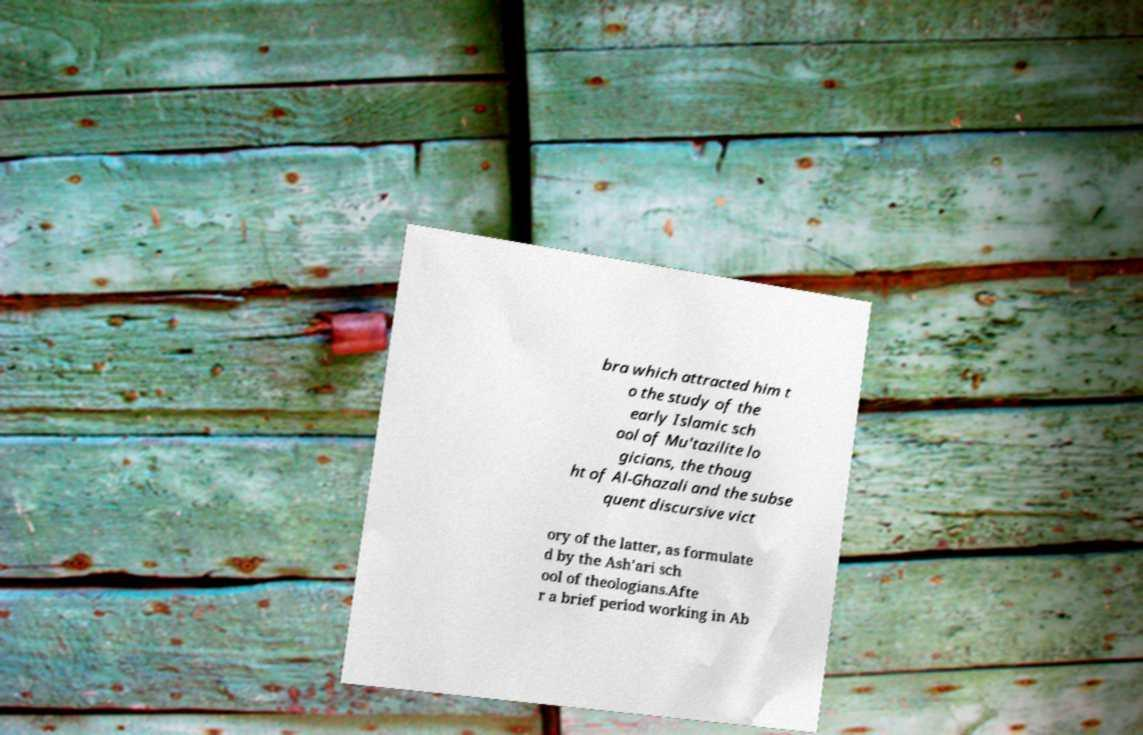Can you read and provide the text displayed in the image?This photo seems to have some interesting text. Can you extract and type it out for me? bra which attracted him t o the study of the early Islamic sch ool of Mu'tazilite lo gicians, the thoug ht of Al-Ghazali and the subse quent discursive vict ory of the latter, as formulate d by the Ash'ari sch ool of theologians.Afte r a brief period working in Ab 